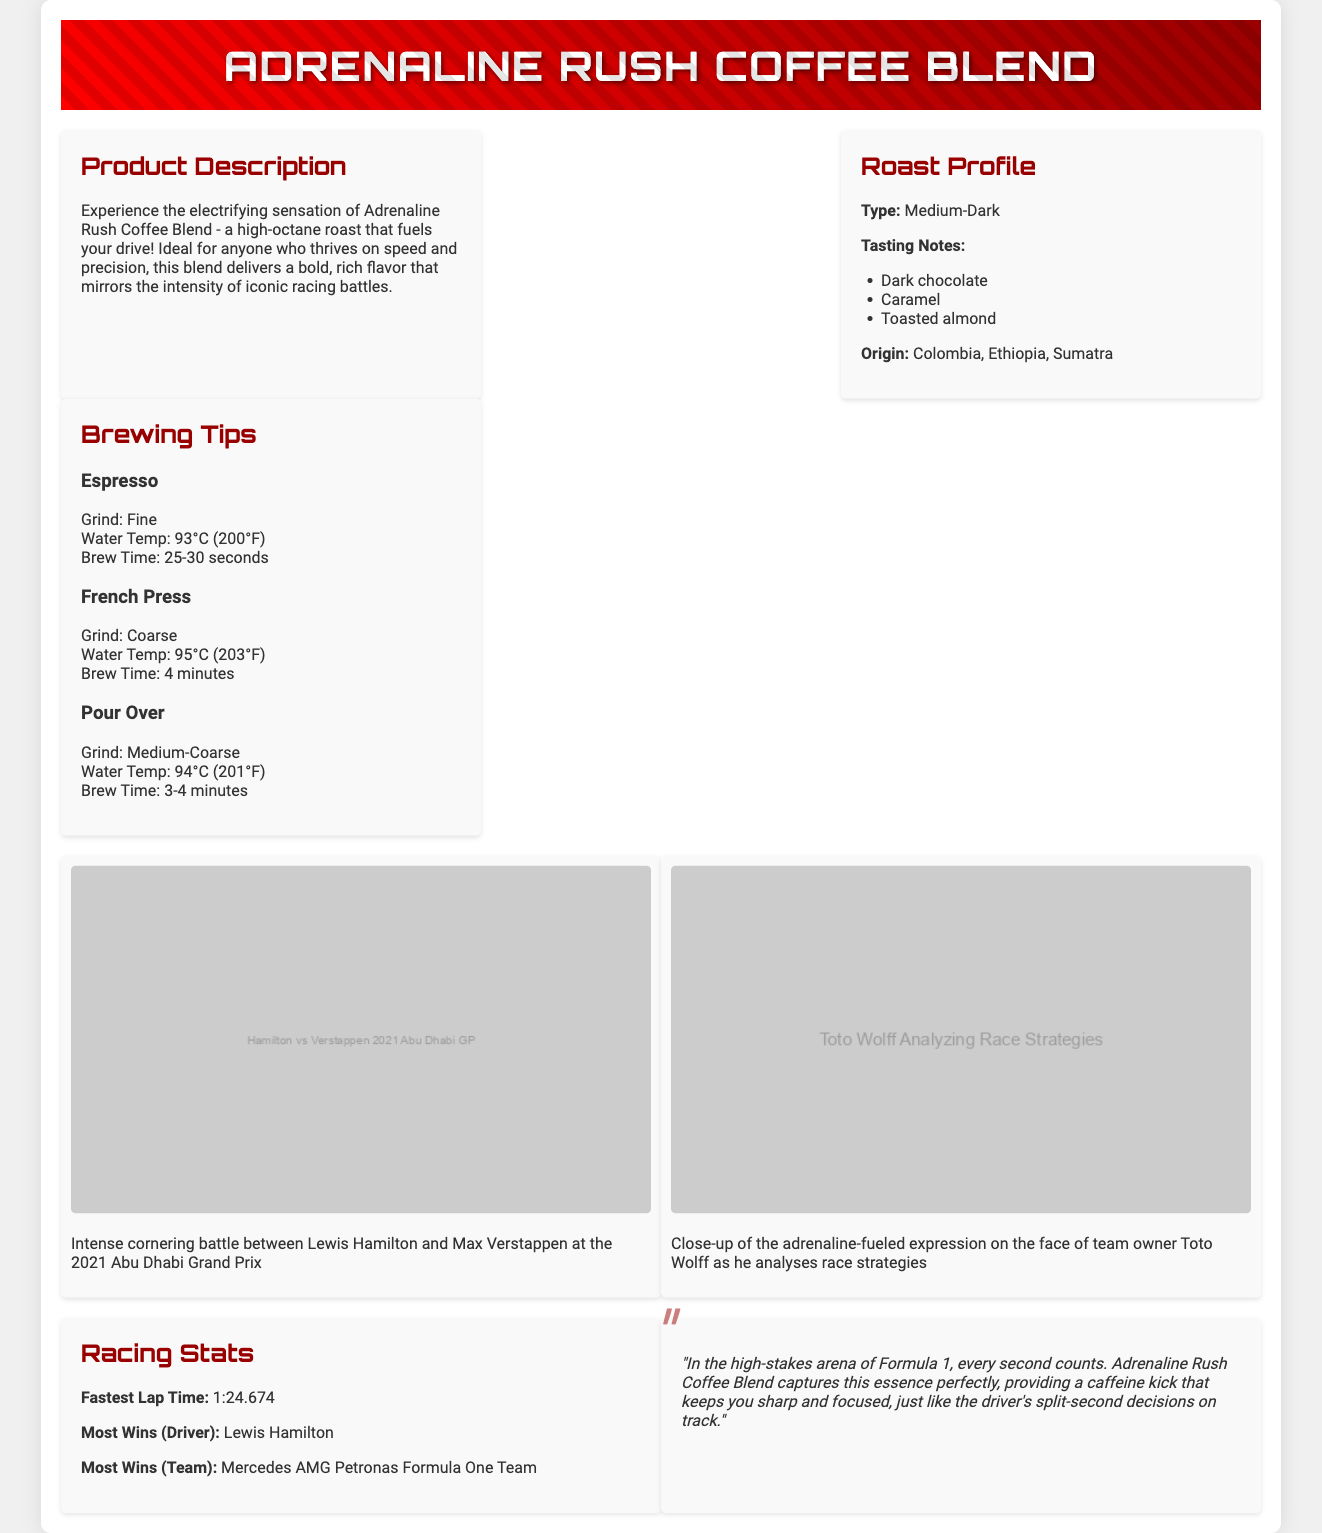What is the type of roast for Adrenaline Rush Coffee Blend? The type of roast for Adrenaline Rush Coffee Blend is provided in the roast profile section of the document.
Answer: Medium-Dark What are the tasting notes mentioned for this coffee blend? The tasting notes are listed in the roast profile section and indicate specific flavors found in the coffee.
Answer: Dark chocolate, Caramel, Toasted almond What are the brewing tips for French Press? Brewing tips are given for different coffee-making methods, including specific instructions for the French Press.
Answer: Grind: Coarse, Water Temp: 95°C (203°F), Brew Time: 4 minutes Who is mentioned as having the most wins as a driver? The racing stats section states who holds the record for the most wins among drivers in Formula 1.
Answer: Lewis Hamilton What is the fastest lap time mentioned in the document? The racing stats section contains a specific time recorded for the fastest lap.
Answer: 1:24.674 What is the recommended water temperature for Pour Over brewing? Brewing tips provide the necessary temperature settings for various methods, including Pour Over.
Answer: 94°C (201°F) What is the quote about caffeine in relation to racing? The commentator's quote captures the essence of the coffee blend's effect as related to racing.
Answer: "In the high-stakes arena of Formula 1, every second counts. Adrenaline Rush Coffee Blend captures this essence perfectly, providing a caffeine kick that keeps you sharp and focused, just like the driver's split-second decisions on track." Which team is noted for having the most wins? The racing stats specify the team with the most wins in Formula 1.
Answer: Mercedes AMG Petronas Formula One Team 